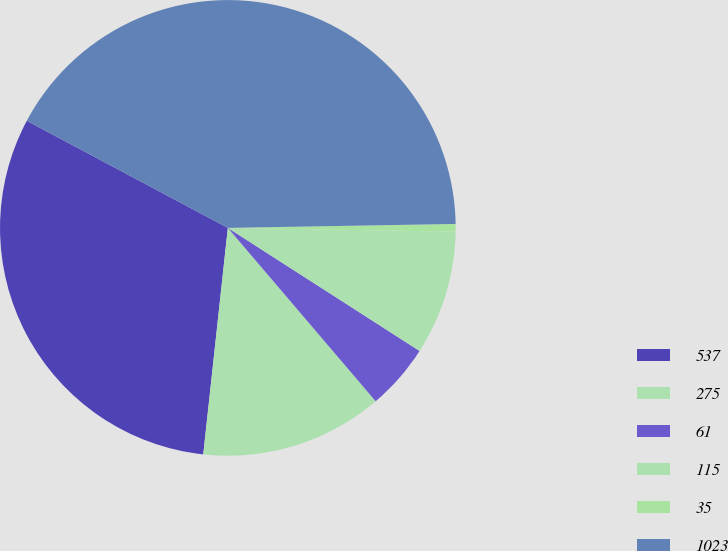<chart> <loc_0><loc_0><loc_500><loc_500><pie_chart><fcel>537<fcel>275<fcel>61<fcel>115<fcel>35<fcel>1023<nl><fcel>31.07%<fcel>12.96%<fcel>4.68%<fcel>8.82%<fcel>0.54%<fcel>41.94%<nl></chart> 